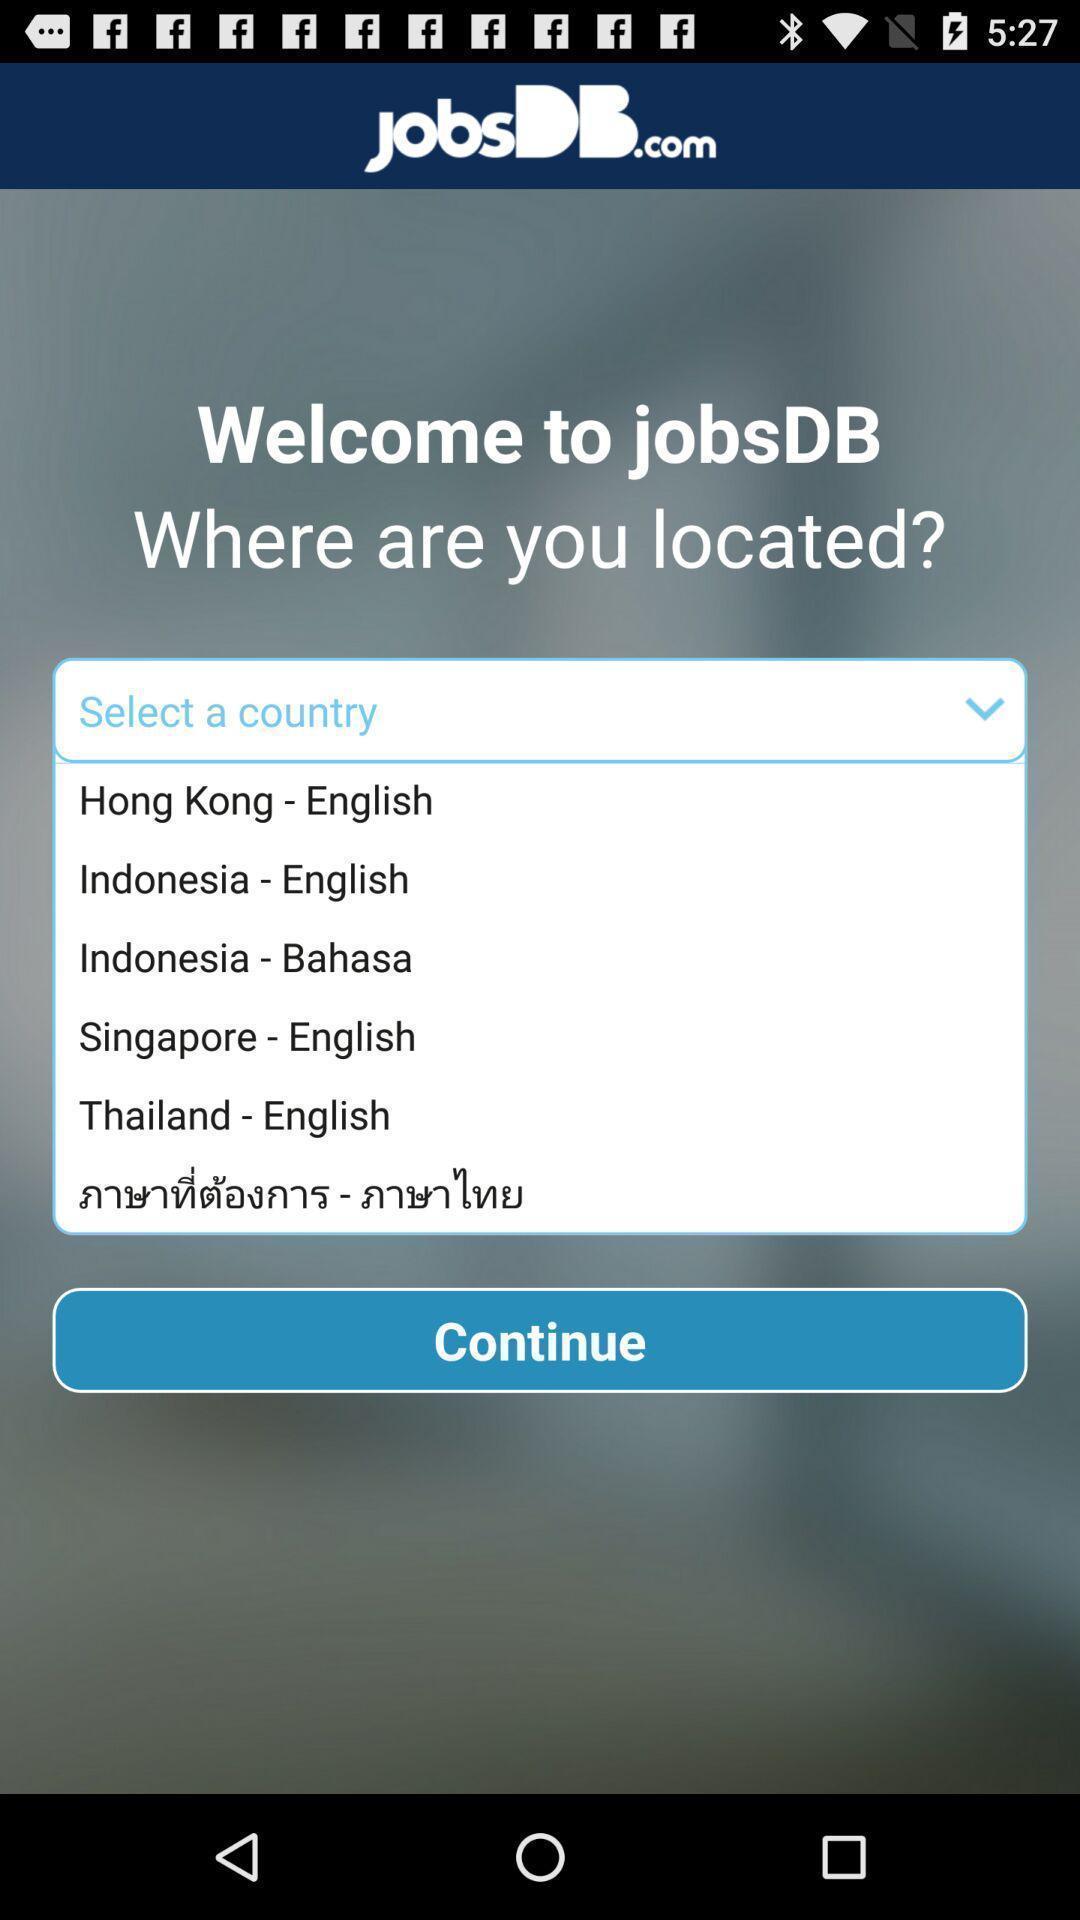Please provide a description for this image. Welcome page is about the jobs with the location. 